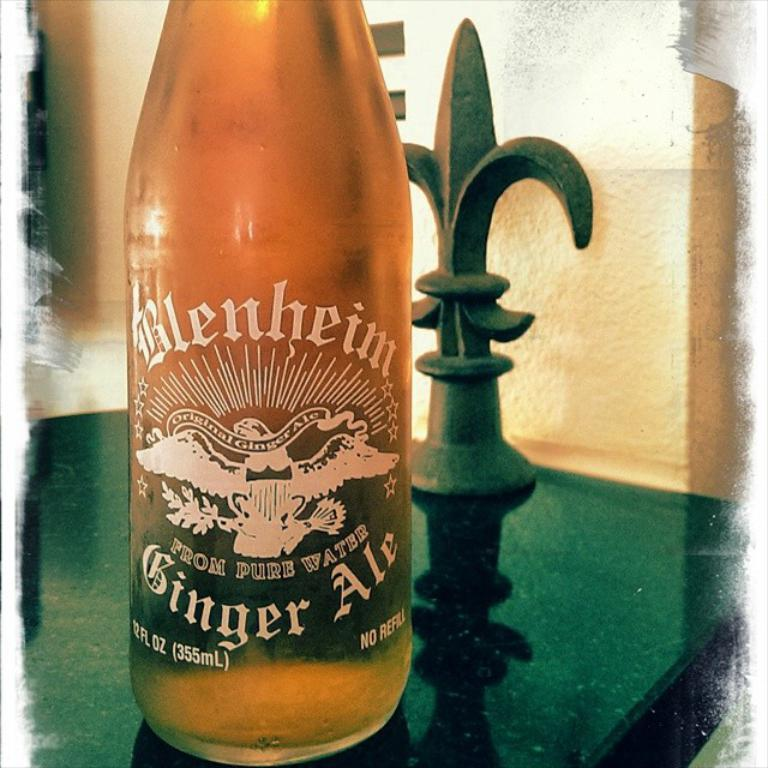Provide a one-sentence caption for the provided image. A bottle of amber color Blenheim Ginger Ale sitting on a dark counter top. 